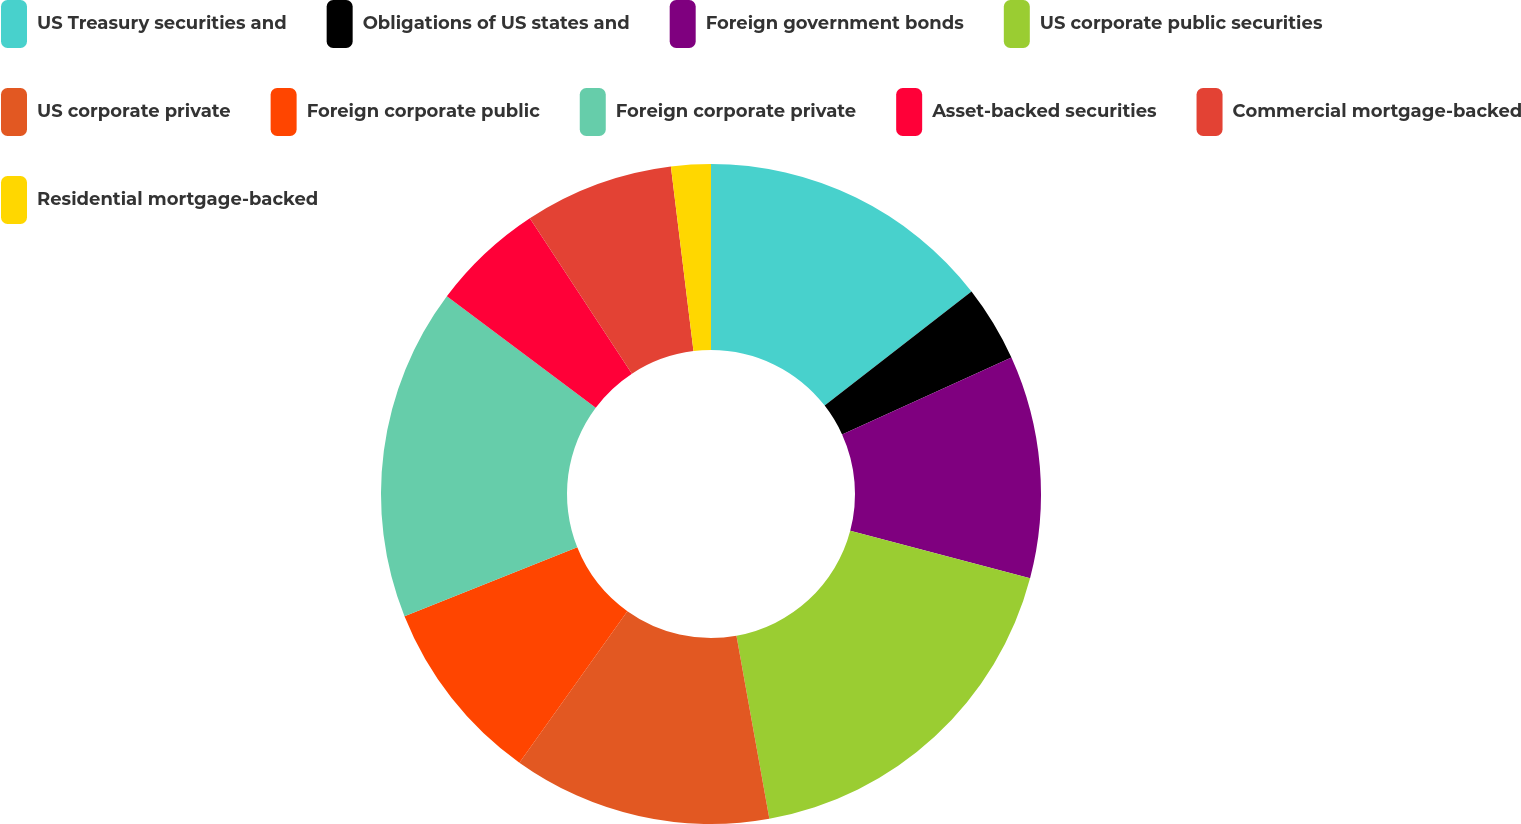<chart> <loc_0><loc_0><loc_500><loc_500><pie_chart><fcel>US Treasury securities and<fcel>Obligations of US states and<fcel>Foreign government bonds<fcel>US corporate public securities<fcel>US corporate private<fcel>Foreign corporate public<fcel>Foreign corporate private<fcel>Asset-backed securities<fcel>Commercial mortgage-backed<fcel>Residential mortgage-backed<nl><fcel>14.48%<fcel>3.73%<fcel>10.9%<fcel>18.06%<fcel>12.69%<fcel>9.1%<fcel>16.27%<fcel>5.52%<fcel>7.31%<fcel>1.94%<nl></chart> 